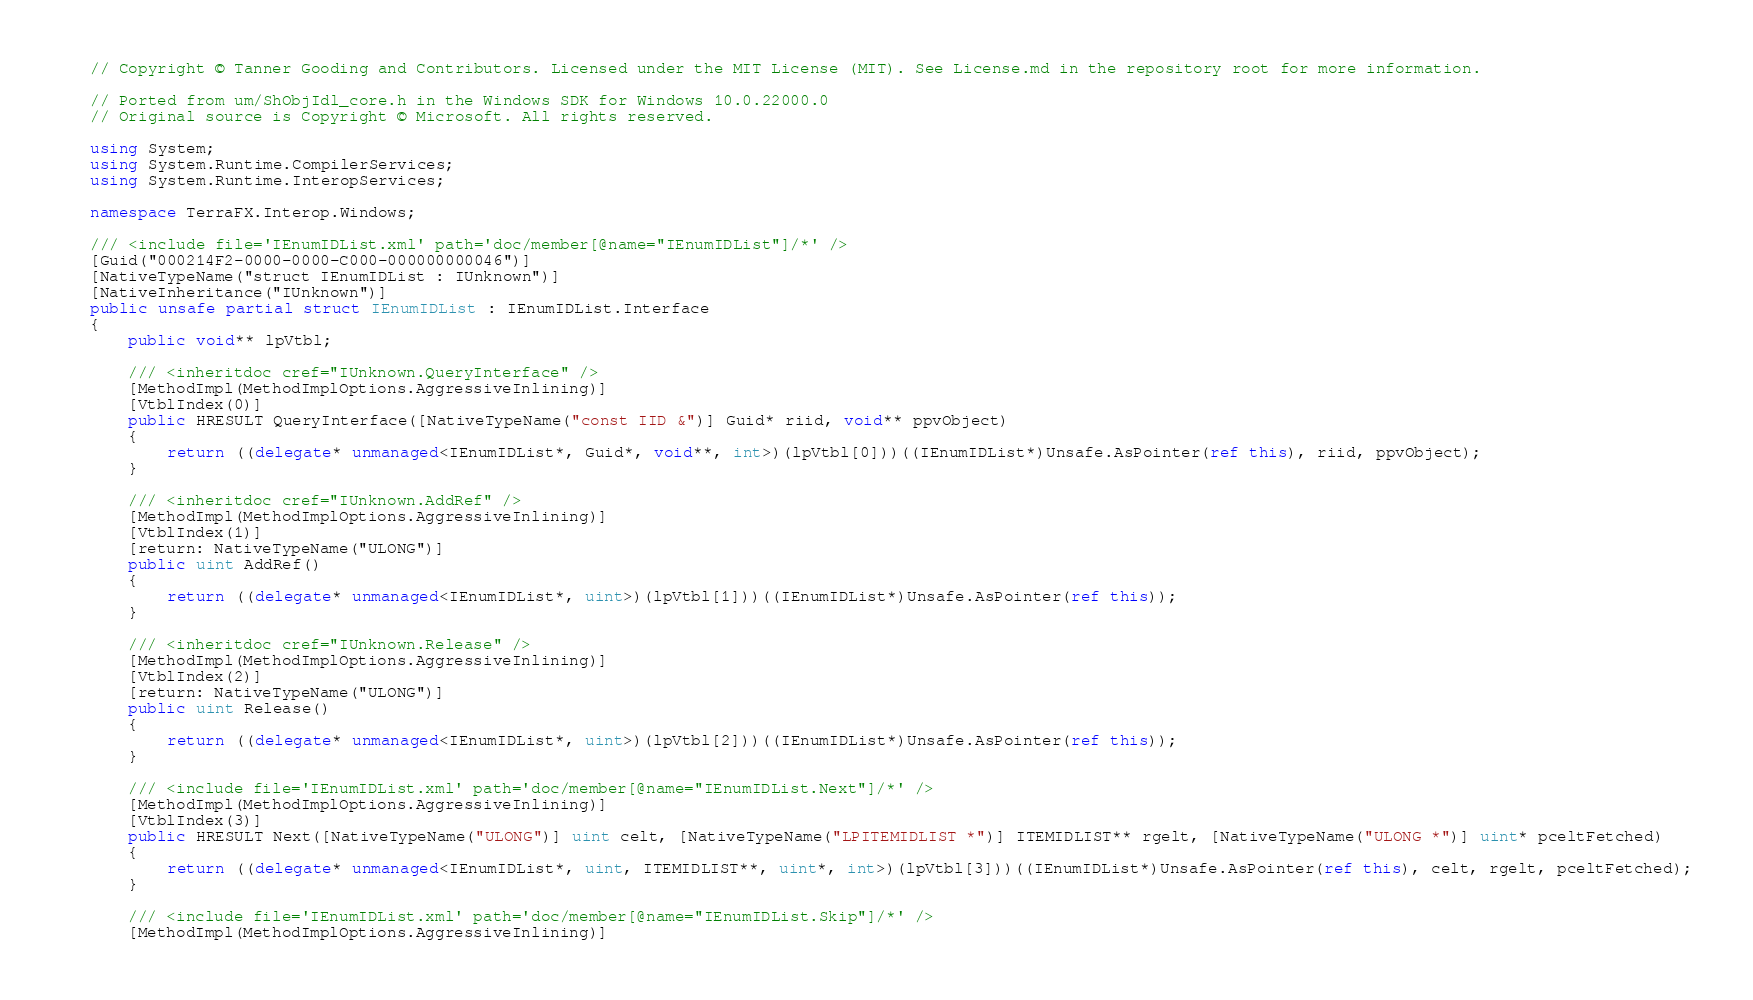Convert code to text. <code><loc_0><loc_0><loc_500><loc_500><_C#_>// Copyright © Tanner Gooding and Contributors. Licensed under the MIT License (MIT). See License.md in the repository root for more information.

// Ported from um/ShObjIdl_core.h in the Windows SDK for Windows 10.0.22000.0
// Original source is Copyright © Microsoft. All rights reserved.

using System;
using System.Runtime.CompilerServices;
using System.Runtime.InteropServices;

namespace TerraFX.Interop.Windows;

/// <include file='IEnumIDList.xml' path='doc/member[@name="IEnumIDList"]/*' />
[Guid("000214F2-0000-0000-C000-000000000046")]
[NativeTypeName("struct IEnumIDList : IUnknown")]
[NativeInheritance("IUnknown")]
public unsafe partial struct IEnumIDList : IEnumIDList.Interface
{
    public void** lpVtbl;

    /// <inheritdoc cref="IUnknown.QueryInterface" />
    [MethodImpl(MethodImplOptions.AggressiveInlining)]
    [VtblIndex(0)]
    public HRESULT QueryInterface([NativeTypeName("const IID &")] Guid* riid, void** ppvObject)
    {
        return ((delegate* unmanaged<IEnumIDList*, Guid*, void**, int>)(lpVtbl[0]))((IEnumIDList*)Unsafe.AsPointer(ref this), riid, ppvObject);
    }

    /// <inheritdoc cref="IUnknown.AddRef" />
    [MethodImpl(MethodImplOptions.AggressiveInlining)]
    [VtblIndex(1)]
    [return: NativeTypeName("ULONG")]
    public uint AddRef()
    {
        return ((delegate* unmanaged<IEnumIDList*, uint>)(lpVtbl[1]))((IEnumIDList*)Unsafe.AsPointer(ref this));
    }

    /// <inheritdoc cref="IUnknown.Release" />
    [MethodImpl(MethodImplOptions.AggressiveInlining)]
    [VtblIndex(2)]
    [return: NativeTypeName("ULONG")]
    public uint Release()
    {
        return ((delegate* unmanaged<IEnumIDList*, uint>)(lpVtbl[2]))((IEnumIDList*)Unsafe.AsPointer(ref this));
    }

    /// <include file='IEnumIDList.xml' path='doc/member[@name="IEnumIDList.Next"]/*' />
    [MethodImpl(MethodImplOptions.AggressiveInlining)]
    [VtblIndex(3)]
    public HRESULT Next([NativeTypeName("ULONG")] uint celt, [NativeTypeName("LPITEMIDLIST *")] ITEMIDLIST** rgelt, [NativeTypeName("ULONG *")] uint* pceltFetched)
    {
        return ((delegate* unmanaged<IEnumIDList*, uint, ITEMIDLIST**, uint*, int>)(lpVtbl[3]))((IEnumIDList*)Unsafe.AsPointer(ref this), celt, rgelt, pceltFetched);
    }

    /// <include file='IEnumIDList.xml' path='doc/member[@name="IEnumIDList.Skip"]/*' />
    [MethodImpl(MethodImplOptions.AggressiveInlining)]</code> 